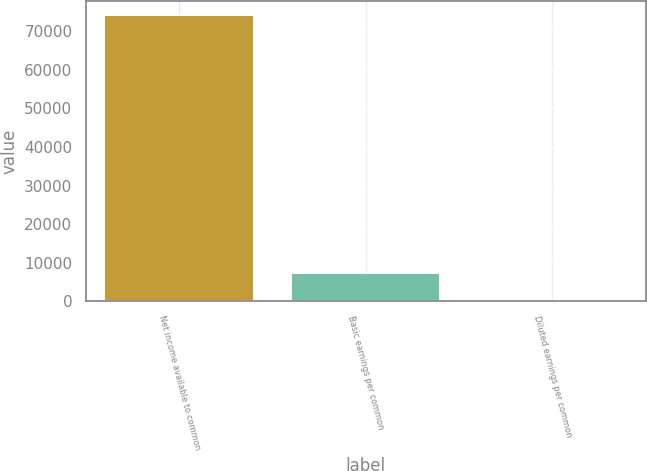Convert chart. <chart><loc_0><loc_0><loc_500><loc_500><bar_chart><fcel>Net income available to common<fcel>Basic earnings per common<fcel>Diluted earnings per common<nl><fcel>74136<fcel>7416.16<fcel>2.85<nl></chart> 